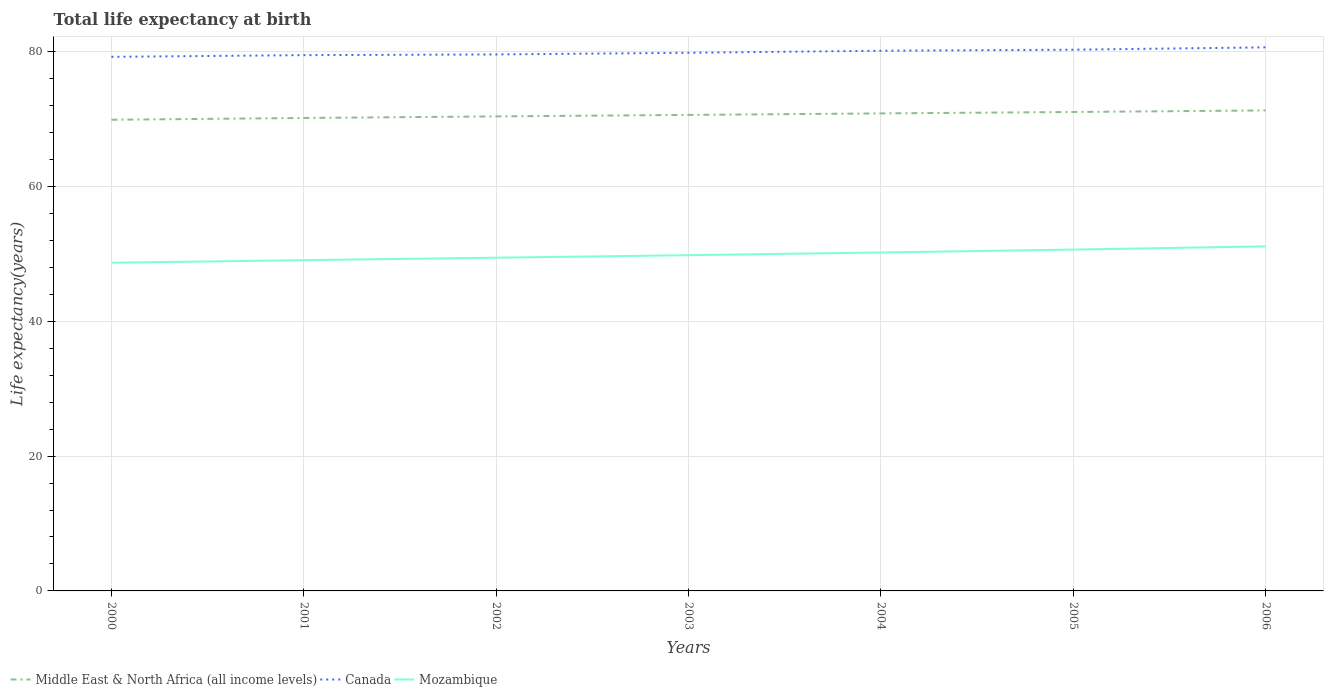Is the number of lines equal to the number of legend labels?
Provide a short and direct response. Yes. Across all years, what is the maximum life expectancy at birth in in Canada?
Provide a succinct answer. 79.24. What is the total life expectancy at birth in in Mozambique in the graph?
Provide a succinct answer. -0.38. What is the difference between the highest and the second highest life expectancy at birth in in Canada?
Offer a terse response. 1.41. How many lines are there?
Offer a very short reply. 3. What is the difference between two consecutive major ticks on the Y-axis?
Provide a succinct answer. 20. Does the graph contain any zero values?
Your response must be concise. No. Does the graph contain grids?
Provide a short and direct response. Yes. How are the legend labels stacked?
Offer a terse response. Horizontal. What is the title of the graph?
Your answer should be very brief. Total life expectancy at birth. What is the label or title of the X-axis?
Your answer should be very brief. Years. What is the label or title of the Y-axis?
Keep it short and to the point. Life expectancy(years). What is the Life expectancy(years) of Middle East & North Africa (all income levels) in 2000?
Provide a short and direct response. 69.9. What is the Life expectancy(years) of Canada in 2000?
Provide a succinct answer. 79.24. What is the Life expectancy(years) of Mozambique in 2000?
Give a very brief answer. 48.69. What is the Life expectancy(years) in Middle East & North Africa (all income levels) in 2001?
Your response must be concise. 70.17. What is the Life expectancy(years) in Canada in 2001?
Provide a short and direct response. 79.49. What is the Life expectancy(years) in Mozambique in 2001?
Offer a terse response. 49.07. What is the Life expectancy(years) of Middle East & North Africa (all income levels) in 2002?
Give a very brief answer. 70.4. What is the Life expectancy(years) of Canada in 2002?
Offer a terse response. 79.59. What is the Life expectancy(years) in Mozambique in 2002?
Your answer should be very brief. 49.44. What is the Life expectancy(years) of Middle East & North Africa (all income levels) in 2003?
Your response must be concise. 70.62. What is the Life expectancy(years) in Canada in 2003?
Your response must be concise. 79.84. What is the Life expectancy(years) in Mozambique in 2003?
Keep it short and to the point. 49.81. What is the Life expectancy(years) in Middle East & North Africa (all income levels) in 2004?
Provide a succinct answer. 70.84. What is the Life expectancy(years) of Canada in 2004?
Ensure brevity in your answer.  80.14. What is the Life expectancy(years) in Mozambique in 2004?
Provide a short and direct response. 50.21. What is the Life expectancy(years) in Middle East & North Africa (all income levels) in 2005?
Provide a succinct answer. 71.05. What is the Life expectancy(years) of Canada in 2005?
Ensure brevity in your answer.  80.29. What is the Life expectancy(years) in Mozambique in 2005?
Give a very brief answer. 50.64. What is the Life expectancy(years) of Middle East & North Africa (all income levels) in 2006?
Your answer should be very brief. 71.28. What is the Life expectancy(years) in Canada in 2006?
Ensure brevity in your answer.  80.64. What is the Life expectancy(years) of Mozambique in 2006?
Your response must be concise. 51.12. Across all years, what is the maximum Life expectancy(years) in Middle East & North Africa (all income levels)?
Your answer should be compact. 71.28. Across all years, what is the maximum Life expectancy(years) of Canada?
Provide a succinct answer. 80.64. Across all years, what is the maximum Life expectancy(years) of Mozambique?
Make the answer very short. 51.12. Across all years, what is the minimum Life expectancy(years) of Middle East & North Africa (all income levels)?
Your answer should be compact. 69.9. Across all years, what is the minimum Life expectancy(years) of Canada?
Keep it short and to the point. 79.24. Across all years, what is the minimum Life expectancy(years) of Mozambique?
Make the answer very short. 48.69. What is the total Life expectancy(years) in Middle East & North Africa (all income levels) in the graph?
Your answer should be compact. 494.27. What is the total Life expectancy(years) of Canada in the graph?
Provide a succinct answer. 559.23. What is the total Life expectancy(years) of Mozambique in the graph?
Ensure brevity in your answer.  348.97. What is the difference between the Life expectancy(years) in Middle East & North Africa (all income levels) in 2000 and that in 2001?
Your response must be concise. -0.26. What is the difference between the Life expectancy(years) in Canada in 2000 and that in 2001?
Give a very brief answer. -0.25. What is the difference between the Life expectancy(years) in Mozambique in 2000 and that in 2001?
Give a very brief answer. -0.38. What is the difference between the Life expectancy(years) of Middle East & North Africa (all income levels) in 2000 and that in 2002?
Ensure brevity in your answer.  -0.5. What is the difference between the Life expectancy(years) of Canada in 2000 and that in 2002?
Offer a terse response. -0.35. What is the difference between the Life expectancy(years) of Mozambique in 2000 and that in 2002?
Give a very brief answer. -0.75. What is the difference between the Life expectancy(years) of Middle East & North Africa (all income levels) in 2000 and that in 2003?
Offer a very short reply. -0.72. What is the difference between the Life expectancy(years) of Canada in 2000 and that in 2003?
Make the answer very short. -0.6. What is the difference between the Life expectancy(years) in Mozambique in 2000 and that in 2003?
Provide a succinct answer. -1.12. What is the difference between the Life expectancy(years) of Middle East & North Africa (all income levels) in 2000 and that in 2004?
Ensure brevity in your answer.  -0.94. What is the difference between the Life expectancy(years) in Canada in 2000 and that in 2004?
Give a very brief answer. -0.9. What is the difference between the Life expectancy(years) of Mozambique in 2000 and that in 2004?
Make the answer very short. -1.52. What is the difference between the Life expectancy(years) of Middle East & North Africa (all income levels) in 2000 and that in 2005?
Ensure brevity in your answer.  -1.15. What is the difference between the Life expectancy(years) of Canada in 2000 and that in 2005?
Provide a short and direct response. -1.06. What is the difference between the Life expectancy(years) in Mozambique in 2000 and that in 2005?
Keep it short and to the point. -1.96. What is the difference between the Life expectancy(years) in Middle East & North Africa (all income levels) in 2000 and that in 2006?
Offer a very short reply. -1.38. What is the difference between the Life expectancy(years) of Canada in 2000 and that in 2006?
Make the answer very short. -1.41. What is the difference between the Life expectancy(years) in Mozambique in 2000 and that in 2006?
Ensure brevity in your answer.  -2.43. What is the difference between the Life expectancy(years) in Middle East & North Africa (all income levels) in 2001 and that in 2002?
Offer a very short reply. -0.23. What is the difference between the Life expectancy(years) of Canada in 2001 and that in 2002?
Your answer should be very brief. -0.1. What is the difference between the Life expectancy(years) in Mozambique in 2001 and that in 2002?
Your answer should be very brief. -0.37. What is the difference between the Life expectancy(years) in Middle East & North Africa (all income levels) in 2001 and that in 2003?
Your answer should be very brief. -0.45. What is the difference between the Life expectancy(years) in Canada in 2001 and that in 2003?
Provide a succinct answer. -0.35. What is the difference between the Life expectancy(years) of Mozambique in 2001 and that in 2003?
Provide a succinct answer. -0.74. What is the difference between the Life expectancy(years) of Middle East & North Africa (all income levels) in 2001 and that in 2004?
Your response must be concise. -0.68. What is the difference between the Life expectancy(years) in Canada in 2001 and that in 2004?
Ensure brevity in your answer.  -0.65. What is the difference between the Life expectancy(years) of Mozambique in 2001 and that in 2004?
Provide a short and direct response. -1.14. What is the difference between the Life expectancy(years) in Middle East & North Africa (all income levels) in 2001 and that in 2005?
Offer a very short reply. -0.89. What is the difference between the Life expectancy(years) in Canada in 2001 and that in 2005?
Provide a succinct answer. -0.8. What is the difference between the Life expectancy(years) in Mozambique in 2001 and that in 2005?
Offer a terse response. -1.57. What is the difference between the Life expectancy(years) in Middle East & North Africa (all income levels) in 2001 and that in 2006?
Your response must be concise. -1.12. What is the difference between the Life expectancy(years) of Canada in 2001 and that in 2006?
Make the answer very short. -1.16. What is the difference between the Life expectancy(years) of Mozambique in 2001 and that in 2006?
Your answer should be compact. -2.04. What is the difference between the Life expectancy(years) in Middle East & North Africa (all income levels) in 2002 and that in 2003?
Provide a short and direct response. -0.22. What is the difference between the Life expectancy(years) of Canada in 2002 and that in 2003?
Offer a very short reply. -0.25. What is the difference between the Life expectancy(years) of Mozambique in 2002 and that in 2003?
Ensure brevity in your answer.  -0.38. What is the difference between the Life expectancy(years) in Middle East & North Africa (all income levels) in 2002 and that in 2004?
Offer a very short reply. -0.44. What is the difference between the Life expectancy(years) of Canada in 2002 and that in 2004?
Ensure brevity in your answer.  -0.55. What is the difference between the Life expectancy(years) in Mozambique in 2002 and that in 2004?
Give a very brief answer. -0.77. What is the difference between the Life expectancy(years) of Middle East & North Africa (all income levels) in 2002 and that in 2005?
Keep it short and to the point. -0.65. What is the difference between the Life expectancy(years) of Canada in 2002 and that in 2005?
Provide a short and direct response. -0.7. What is the difference between the Life expectancy(years) of Mozambique in 2002 and that in 2005?
Make the answer very short. -1.21. What is the difference between the Life expectancy(years) in Middle East & North Africa (all income levels) in 2002 and that in 2006?
Provide a short and direct response. -0.88. What is the difference between the Life expectancy(years) of Canada in 2002 and that in 2006?
Your response must be concise. -1.05. What is the difference between the Life expectancy(years) of Mozambique in 2002 and that in 2006?
Offer a very short reply. -1.68. What is the difference between the Life expectancy(years) of Middle East & North Africa (all income levels) in 2003 and that in 2004?
Offer a terse response. -0.22. What is the difference between the Life expectancy(years) in Canada in 2003 and that in 2004?
Provide a short and direct response. -0.3. What is the difference between the Life expectancy(years) in Mozambique in 2003 and that in 2004?
Your answer should be very brief. -0.4. What is the difference between the Life expectancy(years) in Middle East & North Africa (all income levels) in 2003 and that in 2005?
Your answer should be very brief. -0.43. What is the difference between the Life expectancy(years) in Canada in 2003 and that in 2005?
Keep it short and to the point. -0.45. What is the difference between the Life expectancy(years) of Mozambique in 2003 and that in 2005?
Provide a short and direct response. -0.83. What is the difference between the Life expectancy(years) of Middle East & North Africa (all income levels) in 2003 and that in 2006?
Provide a short and direct response. -0.66. What is the difference between the Life expectancy(years) of Canada in 2003 and that in 2006?
Give a very brief answer. -0.8. What is the difference between the Life expectancy(years) of Mozambique in 2003 and that in 2006?
Your answer should be very brief. -1.3. What is the difference between the Life expectancy(years) in Middle East & North Africa (all income levels) in 2004 and that in 2005?
Give a very brief answer. -0.21. What is the difference between the Life expectancy(years) in Canada in 2004 and that in 2005?
Your answer should be very brief. -0.15. What is the difference between the Life expectancy(years) of Mozambique in 2004 and that in 2005?
Ensure brevity in your answer.  -0.43. What is the difference between the Life expectancy(years) in Middle East & North Africa (all income levels) in 2004 and that in 2006?
Your response must be concise. -0.44. What is the difference between the Life expectancy(years) in Canada in 2004 and that in 2006?
Make the answer very short. -0.5. What is the difference between the Life expectancy(years) of Mozambique in 2004 and that in 2006?
Your response must be concise. -0.91. What is the difference between the Life expectancy(years) of Middle East & North Africa (all income levels) in 2005 and that in 2006?
Keep it short and to the point. -0.23. What is the difference between the Life expectancy(years) in Canada in 2005 and that in 2006?
Offer a terse response. -0.35. What is the difference between the Life expectancy(years) of Mozambique in 2005 and that in 2006?
Keep it short and to the point. -0.47. What is the difference between the Life expectancy(years) of Middle East & North Africa (all income levels) in 2000 and the Life expectancy(years) of Canada in 2001?
Provide a succinct answer. -9.59. What is the difference between the Life expectancy(years) in Middle East & North Africa (all income levels) in 2000 and the Life expectancy(years) in Mozambique in 2001?
Offer a very short reply. 20.83. What is the difference between the Life expectancy(years) in Canada in 2000 and the Life expectancy(years) in Mozambique in 2001?
Provide a short and direct response. 30.17. What is the difference between the Life expectancy(years) of Middle East & North Africa (all income levels) in 2000 and the Life expectancy(years) of Canada in 2002?
Provide a short and direct response. -9.69. What is the difference between the Life expectancy(years) in Middle East & North Africa (all income levels) in 2000 and the Life expectancy(years) in Mozambique in 2002?
Give a very brief answer. 20.46. What is the difference between the Life expectancy(years) in Canada in 2000 and the Life expectancy(years) in Mozambique in 2002?
Your answer should be compact. 29.8. What is the difference between the Life expectancy(years) in Middle East & North Africa (all income levels) in 2000 and the Life expectancy(years) in Canada in 2003?
Provide a succinct answer. -9.94. What is the difference between the Life expectancy(years) in Middle East & North Africa (all income levels) in 2000 and the Life expectancy(years) in Mozambique in 2003?
Your answer should be very brief. 20.09. What is the difference between the Life expectancy(years) in Canada in 2000 and the Life expectancy(years) in Mozambique in 2003?
Ensure brevity in your answer.  29.43. What is the difference between the Life expectancy(years) of Middle East & North Africa (all income levels) in 2000 and the Life expectancy(years) of Canada in 2004?
Provide a succinct answer. -10.24. What is the difference between the Life expectancy(years) in Middle East & North Africa (all income levels) in 2000 and the Life expectancy(years) in Mozambique in 2004?
Provide a succinct answer. 19.69. What is the difference between the Life expectancy(years) of Canada in 2000 and the Life expectancy(years) of Mozambique in 2004?
Offer a very short reply. 29.03. What is the difference between the Life expectancy(years) in Middle East & North Africa (all income levels) in 2000 and the Life expectancy(years) in Canada in 2005?
Give a very brief answer. -10.39. What is the difference between the Life expectancy(years) in Middle East & North Africa (all income levels) in 2000 and the Life expectancy(years) in Mozambique in 2005?
Provide a short and direct response. 19.26. What is the difference between the Life expectancy(years) of Canada in 2000 and the Life expectancy(years) of Mozambique in 2005?
Your answer should be compact. 28.59. What is the difference between the Life expectancy(years) of Middle East & North Africa (all income levels) in 2000 and the Life expectancy(years) of Canada in 2006?
Ensure brevity in your answer.  -10.74. What is the difference between the Life expectancy(years) of Middle East & North Africa (all income levels) in 2000 and the Life expectancy(years) of Mozambique in 2006?
Your answer should be very brief. 18.79. What is the difference between the Life expectancy(years) in Canada in 2000 and the Life expectancy(years) in Mozambique in 2006?
Make the answer very short. 28.12. What is the difference between the Life expectancy(years) of Middle East & North Africa (all income levels) in 2001 and the Life expectancy(years) of Canada in 2002?
Make the answer very short. -9.43. What is the difference between the Life expectancy(years) in Middle East & North Africa (all income levels) in 2001 and the Life expectancy(years) in Mozambique in 2002?
Offer a terse response. 20.73. What is the difference between the Life expectancy(years) of Canada in 2001 and the Life expectancy(years) of Mozambique in 2002?
Give a very brief answer. 30.05. What is the difference between the Life expectancy(years) in Middle East & North Africa (all income levels) in 2001 and the Life expectancy(years) in Canada in 2003?
Provide a short and direct response. -9.67. What is the difference between the Life expectancy(years) in Middle East & North Africa (all income levels) in 2001 and the Life expectancy(years) in Mozambique in 2003?
Make the answer very short. 20.35. What is the difference between the Life expectancy(years) of Canada in 2001 and the Life expectancy(years) of Mozambique in 2003?
Offer a terse response. 29.68. What is the difference between the Life expectancy(years) in Middle East & North Africa (all income levels) in 2001 and the Life expectancy(years) in Canada in 2004?
Give a very brief answer. -9.98. What is the difference between the Life expectancy(years) in Middle East & North Africa (all income levels) in 2001 and the Life expectancy(years) in Mozambique in 2004?
Ensure brevity in your answer.  19.96. What is the difference between the Life expectancy(years) of Canada in 2001 and the Life expectancy(years) of Mozambique in 2004?
Offer a very short reply. 29.28. What is the difference between the Life expectancy(years) in Middle East & North Africa (all income levels) in 2001 and the Life expectancy(years) in Canada in 2005?
Ensure brevity in your answer.  -10.13. What is the difference between the Life expectancy(years) in Middle East & North Africa (all income levels) in 2001 and the Life expectancy(years) in Mozambique in 2005?
Provide a succinct answer. 19.52. What is the difference between the Life expectancy(years) of Canada in 2001 and the Life expectancy(years) of Mozambique in 2005?
Give a very brief answer. 28.85. What is the difference between the Life expectancy(years) in Middle East & North Africa (all income levels) in 2001 and the Life expectancy(years) in Canada in 2006?
Keep it short and to the point. -10.48. What is the difference between the Life expectancy(years) of Middle East & North Africa (all income levels) in 2001 and the Life expectancy(years) of Mozambique in 2006?
Offer a very short reply. 19.05. What is the difference between the Life expectancy(years) of Canada in 2001 and the Life expectancy(years) of Mozambique in 2006?
Give a very brief answer. 28.37. What is the difference between the Life expectancy(years) of Middle East & North Africa (all income levels) in 2002 and the Life expectancy(years) of Canada in 2003?
Keep it short and to the point. -9.44. What is the difference between the Life expectancy(years) in Middle East & North Africa (all income levels) in 2002 and the Life expectancy(years) in Mozambique in 2003?
Your answer should be very brief. 20.59. What is the difference between the Life expectancy(years) in Canada in 2002 and the Life expectancy(years) in Mozambique in 2003?
Ensure brevity in your answer.  29.78. What is the difference between the Life expectancy(years) of Middle East & North Africa (all income levels) in 2002 and the Life expectancy(years) of Canada in 2004?
Your response must be concise. -9.74. What is the difference between the Life expectancy(years) in Middle East & North Africa (all income levels) in 2002 and the Life expectancy(years) in Mozambique in 2004?
Your answer should be very brief. 20.19. What is the difference between the Life expectancy(years) of Canada in 2002 and the Life expectancy(years) of Mozambique in 2004?
Give a very brief answer. 29.38. What is the difference between the Life expectancy(years) of Middle East & North Africa (all income levels) in 2002 and the Life expectancy(years) of Canada in 2005?
Give a very brief answer. -9.89. What is the difference between the Life expectancy(years) of Middle East & North Africa (all income levels) in 2002 and the Life expectancy(years) of Mozambique in 2005?
Provide a short and direct response. 19.76. What is the difference between the Life expectancy(years) of Canada in 2002 and the Life expectancy(years) of Mozambique in 2005?
Your answer should be very brief. 28.95. What is the difference between the Life expectancy(years) in Middle East & North Africa (all income levels) in 2002 and the Life expectancy(years) in Canada in 2006?
Give a very brief answer. -10.24. What is the difference between the Life expectancy(years) in Middle East & North Africa (all income levels) in 2002 and the Life expectancy(years) in Mozambique in 2006?
Ensure brevity in your answer.  19.28. What is the difference between the Life expectancy(years) of Canada in 2002 and the Life expectancy(years) of Mozambique in 2006?
Your answer should be compact. 28.48. What is the difference between the Life expectancy(years) in Middle East & North Africa (all income levels) in 2003 and the Life expectancy(years) in Canada in 2004?
Ensure brevity in your answer.  -9.52. What is the difference between the Life expectancy(years) of Middle East & North Africa (all income levels) in 2003 and the Life expectancy(years) of Mozambique in 2004?
Offer a terse response. 20.41. What is the difference between the Life expectancy(years) of Canada in 2003 and the Life expectancy(years) of Mozambique in 2004?
Offer a terse response. 29.63. What is the difference between the Life expectancy(years) in Middle East & North Africa (all income levels) in 2003 and the Life expectancy(years) in Canada in 2005?
Ensure brevity in your answer.  -9.67. What is the difference between the Life expectancy(years) in Middle East & North Africa (all income levels) in 2003 and the Life expectancy(years) in Mozambique in 2005?
Provide a short and direct response. 19.98. What is the difference between the Life expectancy(years) in Canada in 2003 and the Life expectancy(years) in Mozambique in 2005?
Keep it short and to the point. 29.2. What is the difference between the Life expectancy(years) in Middle East & North Africa (all income levels) in 2003 and the Life expectancy(years) in Canada in 2006?
Offer a terse response. -10.02. What is the difference between the Life expectancy(years) in Middle East & North Africa (all income levels) in 2003 and the Life expectancy(years) in Mozambique in 2006?
Provide a succinct answer. 19.5. What is the difference between the Life expectancy(years) of Canada in 2003 and the Life expectancy(years) of Mozambique in 2006?
Provide a succinct answer. 28.72. What is the difference between the Life expectancy(years) of Middle East & North Africa (all income levels) in 2004 and the Life expectancy(years) of Canada in 2005?
Give a very brief answer. -9.45. What is the difference between the Life expectancy(years) in Middle East & North Africa (all income levels) in 2004 and the Life expectancy(years) in Mozambique in 2005?
Offer a very short reply. 20.2. What is the difference between the Life expectancy(years) of Canada in 2004 and the Life expectancy(years) of Mozambique in 2005?
Your answer should be compact. 29.5. What is the difference between the Life expectancy(years) of Middle East & North Africa (all income levels) in 2004 and the Life expectancy(years) of Canada in 2006?
Provide a short and direct response. -9.8. What is the difference between the Life expectancy(years) of Middle East & North Africa (all income levels) in 2004 and the Life expectancy(years) of Mozambique in 2006?
Your answer should be compact. 19.73. What is the difference between the Life expectancy(years) of Canada in 2004 and the Life expectancy(years) of Mozambique in 2006?
Ensure brevity in your answer.  29.03. What is the difference between the Life expectancy(years) of Middle East & North Africa (all income levels) in 2005 and the Life expectancy(years) of Canada in 2006?
Your answer should be very brief. -9.59. What is the difference between the Life expectancy(years) of Middle East & North Africa (all income levels) in 2005 and the Life expectancy(years) of Mozambique in 2006?
Your answer should be compact. 19.94. What is the difference between the Life expectancy(years) of Canada in 2005 and the Life expectancy(years) of Mozambique in 2006?
Provide a succinct answer. 29.18. What is the average Life expectancy(years) in Middle East & North Africa (all income levels) per year?
Keep it short and to the point. 70.61. What is the average Life expectancy(years) of Canada per year?
Make the answer very short. 79.89. What is the average Life expectancy(years) of Mozambique per year?
Your answer should be very brief. 49.85. In the year 2000, what is the difference between the Life expectancy(years) in Middle East & North Africa (all income levels) and Life expectancy(years) in Canada?
Your response must be concise. -9.34. In the year 2000, what is the difference between the Life expectancy(years) of Middle East & North Africa (all income levels) and Life expectancy(years) of Mozambique?
Provide a short and direct response. 21.21. In the year 2000, what is the difference between the Life expectancy(years) in Canada and Life expectancy(years) in Mozambique?
Your answer should be compact. 30.55. In the year 2001, what is the difference between the Life expectancy(years) of Middle East & North Africa (all income levels) and Life expectancy(years) of Canada?
Keep it short and to the point. -9.32. In the year 2001, what is the difference between the Life expectancy(years) in Middle East & North Africa (all income levels) and Life expectancy(years) in Mozambique?
Keep it short and to the point. 21.09. In the year 2001, what is the difference between the Life expectancy(years) in Canada and Life expectancy(years) in Mozambique?
Give a very brief answer. 30.42. In the year 2002, what is the difference between the Life expectancy(years) in Middle East & North Africa (all income levels) and Life expectancy(years) in Canada?
Offer a terse response. -9.19. In the year 2002, what is the difference between the Life expectancy(years) of Middle East & North Africa (all income levels) and Life expectancy(years) of Mozambique?
Make the answer very short. 20.96. In the year 2002, what is the difference between the Life expectancy(years) in Canada and Life expectancy(years) in Mozambique?
Provide a succinct answer. 30.15. In the year 2003, what is the difference between the Life expectancy(years) in Middle East & North Africa (all income levels) and Life expectancy(years) in Canada?
Ensure brevity in your answer.  -9.22. In the year 2003, what is the difference between the Life expectancy(years) of Middle East & North Africa (all income levels) and Life expectancy(years) of Mozambique?
Offer a terse response. 20.81. In the year 2003, what is the difference between the Life expectancy(years) of Canada and Life expectancy(years) of Mozambique?
Make the answer very short. 30.03. In the year 2004, what is the difference between the Life expectancy(years) in Middle East & North Africa (all income levels) and Life expectancy(years) in Canada?
Your answer should be compact. -9.3. In the year 2004, what is the difference between the Life expectancy(years) of Middle East & North Africa (all income levels) and Life expectancy(years) of Mozambique?
Your answer should be very brief. 20.63. In the year 2004, what is the difference between the Life expectancy(years) of Canada and Life expectancy(years) of Mozambique?
Your answer should be compact. 29.93. In the year 2005, what is the difference between the Life expectancy(years) in Middle East & North Africa (all income levels) and Life expectancy(years) in Canada?
Offer a terse response. -9.24. In the year 2005, what is the difference between the Life expectancy(years) in Middle East & North Africa (all income levels) and Life expectancy(years) in Mozambique?
Make the answer very short. 20.41. In the year 2005, what is the difference between the Life expectancy(years) of Canada and Life expectancy(years) of Mozambique?
Provide a succinct answer. 29.65. In the year 2006, what is the difference between the Life expectancy(years) in Middle East & North Africa (all income levels) and Life expectancy(years) in Canada?
Provide a succinct answer. -9.36. In the year 2006, what is the difference between the Life expectancy(years) in Middle East & North Africa (all income levels) and Life expectancy(years) in Mozambique?
Offer a very short reply. 20.17. In the year 2006, what is the difference between the Life expectancy(years) in Canada and Life expectancy(years) in Mozambique?
Keep it short and to the point. 29.53. What is the ratio of the Life expectancy(years) of Middle East & North Africa (all income levels) in 2000 to that in 2001?
Make the answer very short. 1. What is the ratio of the Life expectancy(years) of Middle East & North Africa (all income levels) in 2000 to that in 2002?
Give a very brief answer. 0.99. What is the ratio of the Life expectancy(years) of Canada in 2000 to that in 2002?
Provide a short and direct response. 1. What is the ratio of the Life expectancy(years) of Canada in 2000 to that in 2003?
Offer a terse response. 0.99. What is the ratio of the Life expectancy(years) of Mozambique in 2000 to that in 2003?
Provide a short and direct response. 0.98. What is the ratio of the Life expectancy(years) in Middle East & North Africa (all income levels) in 2000 to that in 2004?
Your response must be concise. 0.99. What is the ratio of the Life expectancy(years) in Canada in 2000 to that in 2004?
Your answer should be compact. 0.99. What is the ratio of the Life expectancy(years) in Mozambique in 2000 to that in 2004?
Give a very brief answer. 0.97. What is the ratio of the Life expectancy(years) of Middle East & North Africa (all income levels) in 2000 to that in 2005?
Make the answer very short. 0.98. What is the ratio of the Life expectancy(years) in Mozambique in 2000 to that in 2005?
Your response must be concise. 0.96. What is the ratio of the Life expectancy(years) in Middle East & North Africa (all income levels) in 2000 to that in 2006?
Provide a succinct answer. 0.98. What is the ratio of the Life expectancy(years) of Canada in 2000 to that in 2006?
Your answer should be very brief. 0.98. What is the ratio of the Life expectancy(years) in Mozambique in 2000 to that in 2006?
Keep it short and to the point. 0.95. What is the ratio of the Life expectancy(years) of Canada in 2001 to that in 2002?
Offer a terse response. 1. What is the ratio of the Life expectancy(years) in Mozambique in 2001 to that in 2002?
Offer a very short reply. 0.99. What is the ratio of the Life expectancy(years) of Canada in 2001 to that in 2003?
Provide a short and direct response. 1. What is the ratio of the Life expectancy(years) in Mozambique in 2001 to that in 2003?
Make the answer very short. 0.99. What is the ratio of the Life expectancy(years) of Middle East & North Africa (all income levels) in 2001 to that in 2004?
Offer a very short reply. 0.99. What is the ratio of the Life expectancy(years) in Canada in 2001 to that in 2004?
Make the answer very short. 0.99. What is the ratio of the Life expectancy(years) in Mozambique in 2001 to that in 2004?
Your answer should be very brief. 0.98. What is the ratio of the Life expectancy(years) of Middle East & North Africa (all income levels) in 2001 to that in 2005?
Offer a very short reply. 0.99. What is the ratio of the Life expectancy(years) in Canada in 2001 to that in 2005?
Offer a terse response. 0.99. What is the ratio of the Life expectancy(years) of Mozambique in 2001 to that in 2005?
Ensure brevity in your answer.  0.97. What is the ratio of the Life expectancy(years) of Middle East & North Africa (all income levels) in 2001 to that in 2006?
Provide a succinct answer. 0.98. What is the ratio of the Life expectancy(years) in Canada in 2001 to that in 2006?
Make the answer very short. 0.99. What is the ratio of the Life expectancy(years) in Mozambique in 2001 to that in 2006?
Provide a short and direct response. 0.96. What is the ratio of the Life expectancy(years) in Middle East & North Africa (all income levels) in 2002 to that in 2003?
Your answer should be compact. 1. What is the ratio of the Life expectancy(years) in Canada in 2002 to that in 2003?
Your answer should be compact. 1. What is the ratio of the Life expectancy(years) of Mozambique in 2002 to that in 2003?
Your answer should be very brief. 0.99. What is the ratio of the Life expectancy(years) in Middle East & North Africa (all income levels) in 2002 to that in 2004?
Provide a short and direct response. 0.99. What is the ratio of the Life expectancy(years) of Mozambique in 2002 to that in 2004?
Offer a very short reply. 0.98. What is the ratio of the Life expectancy(years) of Middle East & North Africa (all income levels) in 2002 to that in 2005?
Your response must be concise. 0.99. What is the ratio of the Life expectancy(years) in Mozambique in 2002 to that in 2005?
Ensure brevity in your answer.  0.98. What is the ratio of the Life expectancy(years) in Middle East & North Africa (all income levels) in 2002 to that in 2006?
Give a very brief answer. 0.99. What is the ratio of the Life expectancy(years) of Canada in 2002 to that in 2006?
Provide a short and direct response. 0.99. What is the ratio of the Life expectancy(years) in Mozambique in 2002 to that in 2006?
Make the answer very short. 0.97. What is the ratio of the Life expectancy(years) of Middle East & North Africa (all income levels) in 2003 to that in 2004?
Your response must be concise. 1. What is the ratio of the Life expectancy(years) of Canada in 2003 to that in 2004?
Provide a short and direct response. 1. What is the ratio of the Life expectancy(years) in Mozambique in 2003 to that in 2004?
Make the answer very short. 0.99. What is the ratio of the Life expectancy(years) in Canada in 2003 to that in 2005?
Make the answer very short. 0.99. What is the ratio of the Life expectancy(years) of Mozambique in 2003 to that in 2005?
Ensure brevity in your answer.  0.98. What is the ratio of the Life expectancy(years) in Middle East & North Africa (all income levels) in 2003 to that in 2006?
Give a very brief answer. 0.99. What is the ratio of the Life expectancy(years) in Mozambique in 2003 to that in 2006?
Your response must be concise. 0.97. What is the ratio of the Life expectancy(years) in Canada in 2004 to that in 2005?
Your answer should be very brief. 1. What is the ratio of the Life expectancy(years) of Mozambique in 2004 to that in 2005?
Offer a very short reply. 0.99. What is the ratio of the Life expectancy(years) of Canada in 2004 to that in 2006?
Your response must be concise. 0.99. What is the ratio of the Life expectancy(years) in Mozambique in 2004 to that in 2006?
Ensure brevity in your answer.  0.98. What is the ratio of the Life expectancy(years) in Middle East & North Africa (all income levels) in 2005 to that in 2006?
Give a very brief answer. 1. What is the ratio of the Life expectancy(years) of Canada in 2005 to that in 2006?
Provide a succinct answer. 1. What is the ratio of the Life expectancy(years) in Mozambique in 2005 to that in 2006?
Your answer should be very brief. 0.99. What is the difference between the highest and the second highest Life expectancy(years) in Middle East & North Africa (all income levels)?
Offer a terse response. 0.23. What is the difference between the highest and the second highest Life expectancy(years) of Canada?
Provide a succinct answer. 0.35. What is the difference between the highest and the second highest Life expectancy(years) in Mozambique?
Your answer should be very brief. 0.47. What is the difference between the highest and the lowest Life expectancy(years) in Middle East & North Africa (all income levels)?
Offer a terse response. 1.38. What is the difference between the highest and the lowest Life expectancy(years) in Canada?
Your response must be concise. 1.41. What is the difference between the highest and the lowest Life expectancy(years) of Mozambique?
Keep it short and to the point. 2.43. 